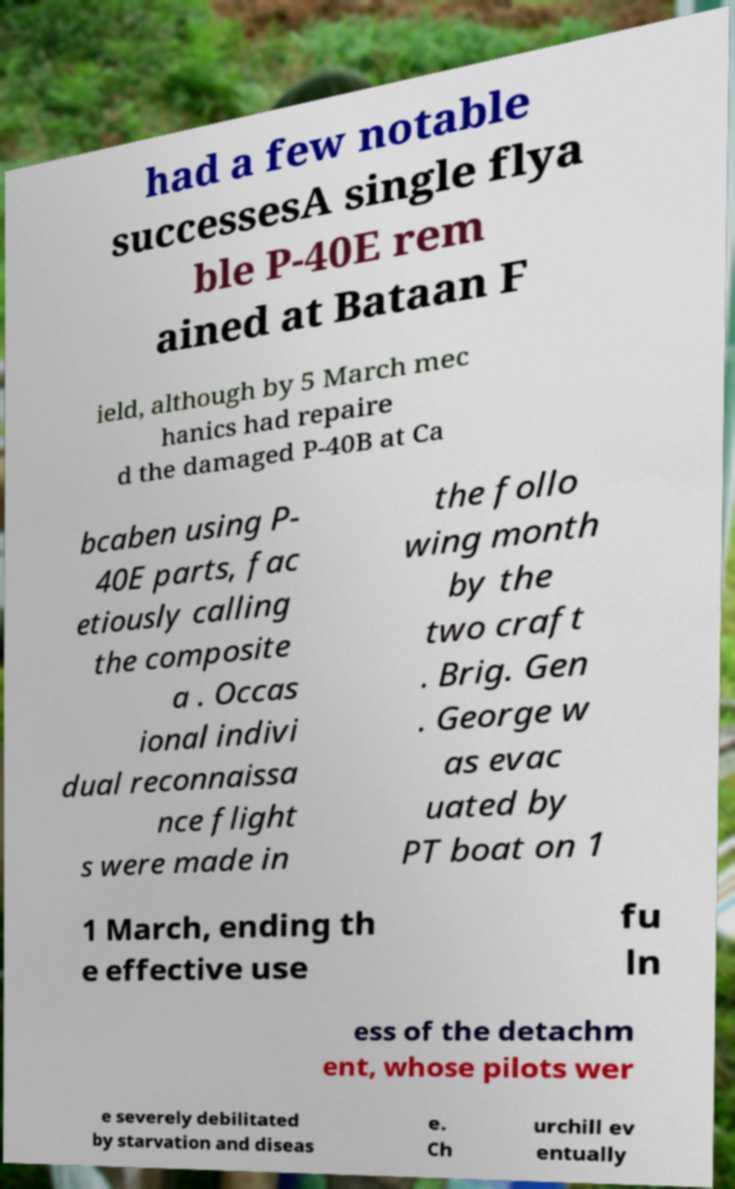For documentation purposes, I need the text within this image transcribed. Could you provide that? had a few notable successesA single flya ble P-40E rem ained at Bataan F ield, although by 5 March mec hanics had repaire d the damaged P-40B at Ca bcaben using P- 40E parts, fac etiously calling the composite a . Occas ional indivi dual reconnaissa nce flight s were made in the follo wing month by the two craft . Brig. Gen . George w as evac uated by PT boat on 1 1 March, ending th e effective use fu ln ess of the detachm ent, whose pilots wer e severely debilitated by starvation and diseas e. Ch urchill ev entually 